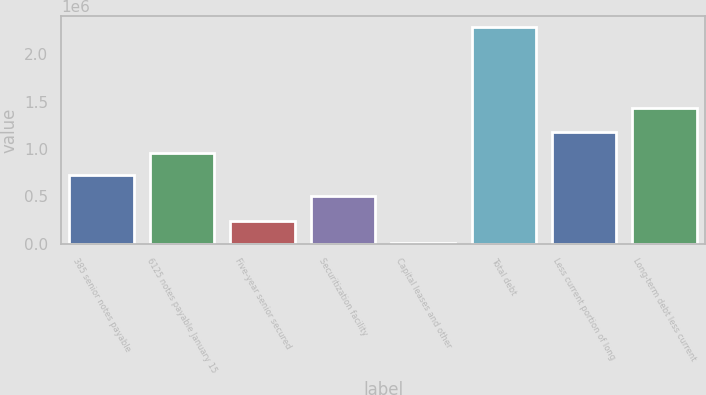Convert chart. <chart><loc_0><loc_0><loc_500><loc_500><bar_chart><fcel>385 senior notes payable<fcel>6125 notes payable January 15<fcel>Five-year senior secured<fcel>Securitization facility<fcel>Capital leases and other<fcel>Total debt<fcel>Less current portion of long<fcel>Long-term debt less current<nl><fcel>727828<fcel>955656<fcel>238448<fcel>500000<fcel>10620<fcel>2.2889e+06<fcel>1.18348e+06<fcel>1.43759e+06<nl></chart> 